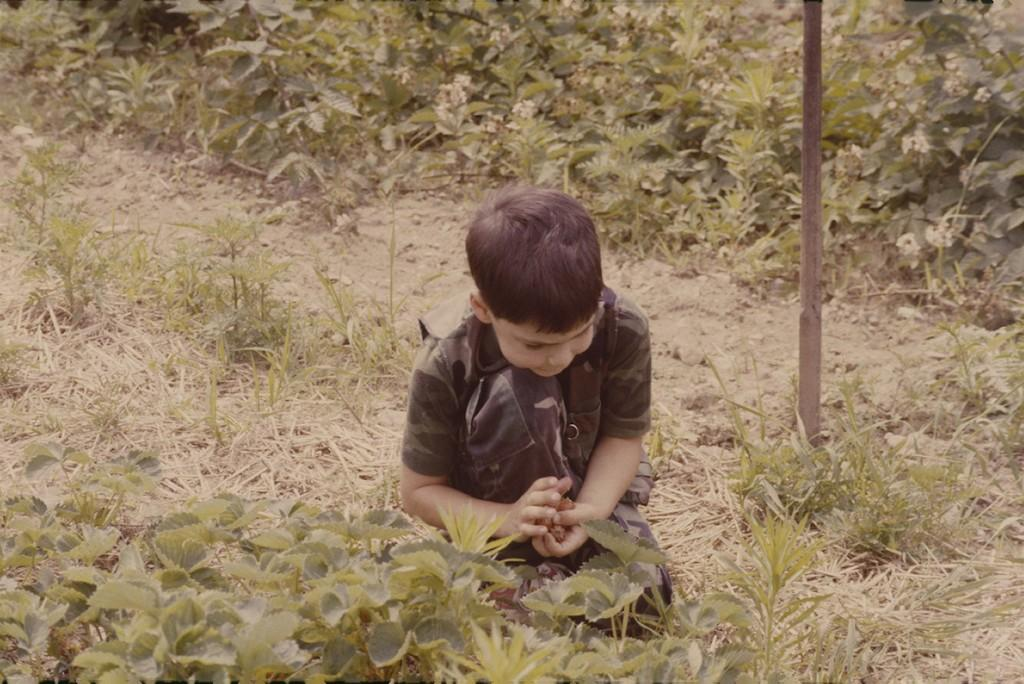Who is present in the image? There is a boy in the image. What can be seen on the ground in the image? There are plants on the ground. What object is on the right side of the image? There is a stick on the right side of the image. What type of soap is the boy holding in the image? There is no soap present in the image; it features a boy, plants, and a stick. 